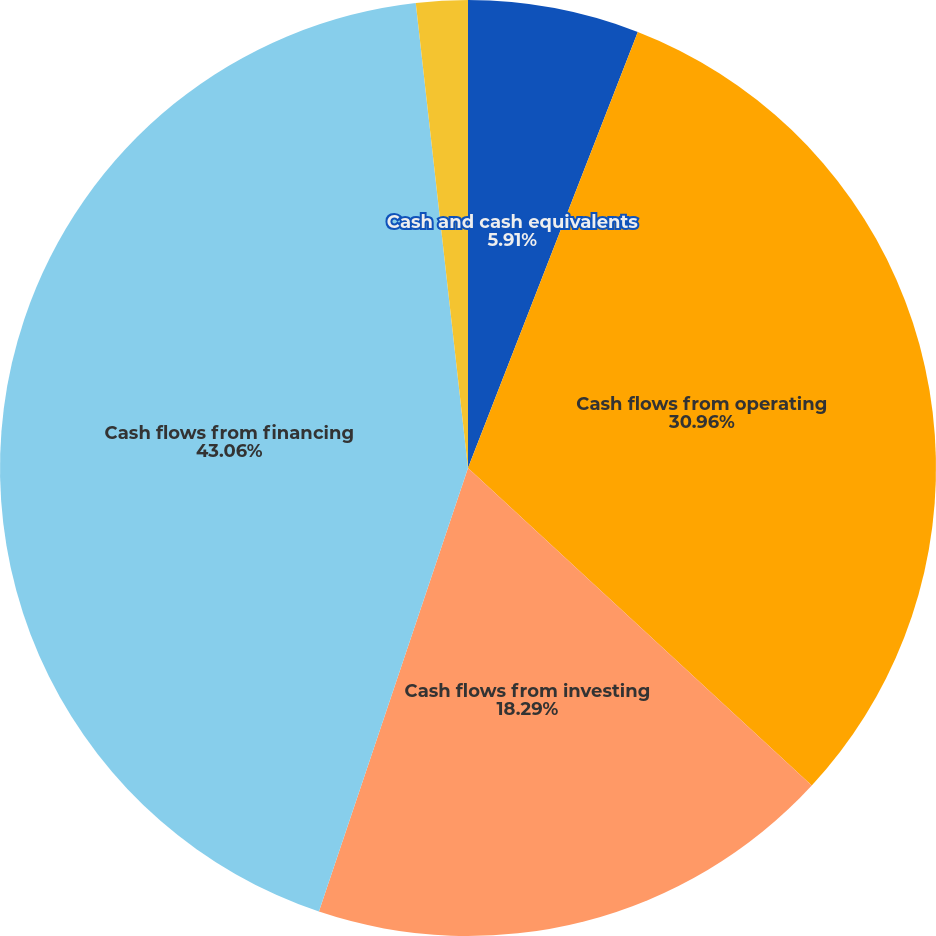Convert chart. <chart><loc_0><loc_0><loc_500><loc_500><pie_chart><fcel>Cash and cash equivalents<fcel>Cash flows from operating<fcel>Cash flows from investing<fcel>Cash flows from financing<fcel>Net change in cash and cash<nl><fcel>5.91%<fcel>30.96%<fcel>18.29%<fcel>43.06%<fcel>1.78%<nl></chart> 